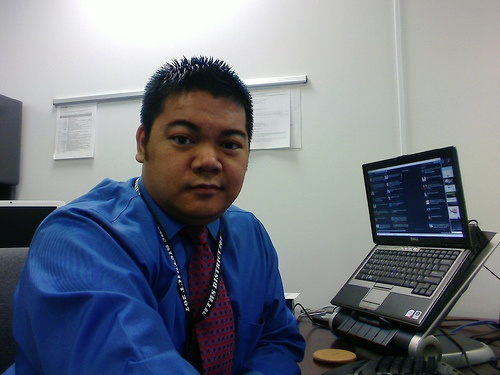Describe the objects in this image and their specific colors. I can see people in darkgray, navy, black, blue, and maroon tones, laptop in darkgray, black, gray, and navy tones, tie in darkgray, black, maroon, and navy tones, keyboard in darkgray, gray, and black tones, and chair in darkgray, black, gray, and darkblue tones in this image. 